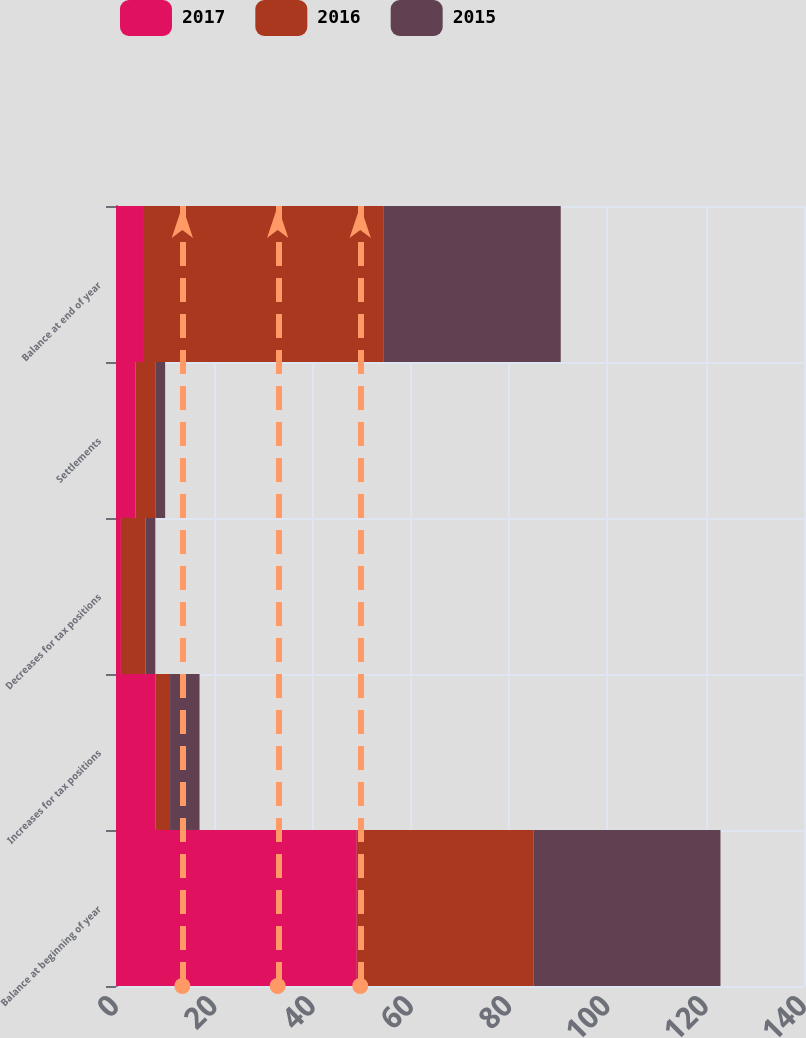<chart> <loc_0><loc_0><loc_500><loc_500><stacked_bar_chart><ecel><fcel>Balance at beginning of year<fcel>Increases for tax positions<fcel>Decreases for tax positions<fcel>Settlements<fcel>Balance at end of year<nl><fcel>2017<fcel>49<fcel>8<fcel>1<fcel>4<fcel>5.5<nl><fcel>2016<fcel>36<fcel>3<fcel>5<fcel>4<fcel>49<nl><fcel>2015<fcel>38<fcel>6<fcel>2<fcel>2<fcel>36<nl></chart> 